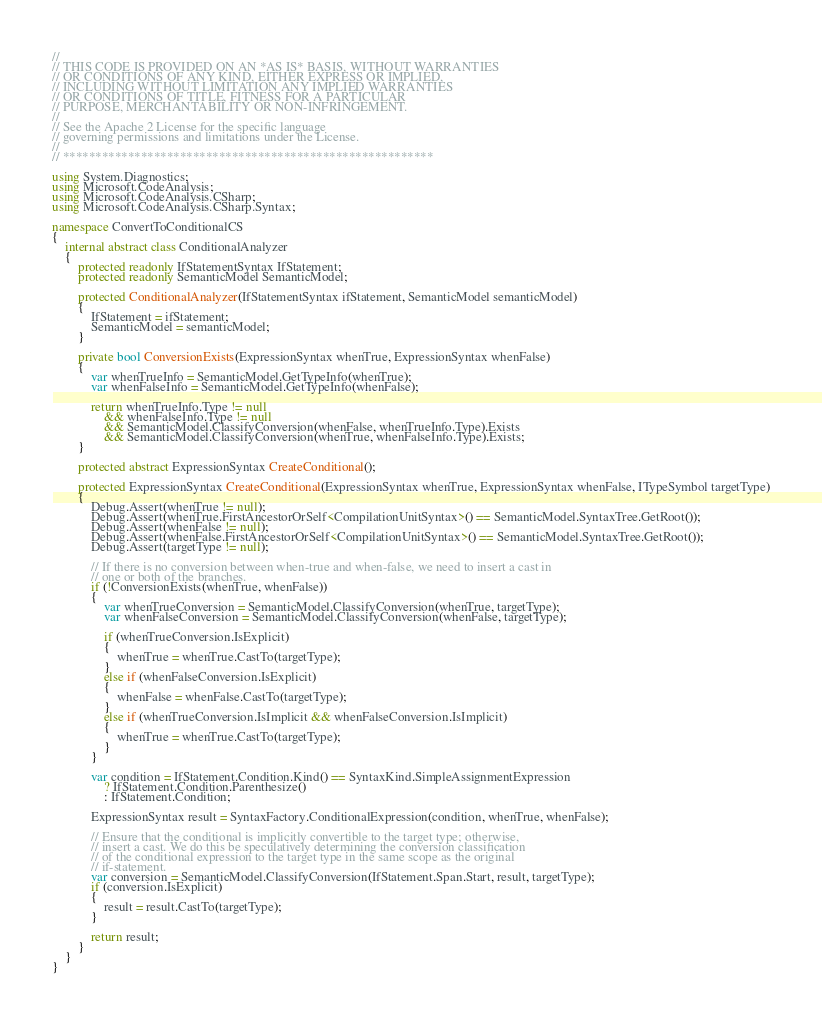<code> <loc_0><loc_0><loc_500><loc_500><_C#_>//
// THIS CODE IS PROVIDED ON AN *AS IS* BASIS, WITHOUT WARRANTIES
// OR CONDITIONS OF ANY KIND, EITHER EXPRESS OR IMPLIED,
// INCLUDING WITHOUT LIMITATION ANY IMPLIED WARRANTIES
// OR CONDITIONS OF TITLE, FITNESS FOR A PARTICULAR
// PURPOSE, MERCHANTABILITY OR NON-INFRINGEMENT.
//
// See the Apache 2 License for the specific language
// governing permissions and limitations under the License.
//
// *********************************************************

using System.Diagnostics;
using Microsoft.CodeAnalysis;
using Microsoft.CodeAnalysis.CSharp;
using Microsoft.CodeAnalysis.CSharp.Syntax;

namespace ConvertToConditionalCS
{
    internal abstract class ConditionalAnalyzer
    {
        protected readonly IfStatementSyntax IfStatement;
        protected readonly SemanticModel SemanticModel;

        protected ConditionalAnalyzer(IfStatementSyntax ifStatement, SemanticModel semanticModel)
        {
            IfStatement = ifStatement;
            SemanticModel = semanticModel;
        }

        private bool ConversionExists(ExpressionSyntax whenTrue, ExpressionSyntax whenFalse)
        {
            var whenTrueInfo = SemanticModel.GetTypeInfo(whenTrue);
            var whenFalseInfo = SemanticModel.GetTypeInfo(whenFalse);

            return whenTrueInfo.Type != null
                && whenFalseInfo.Type != null
                && SemanticModel.ClassifyConversion(whenFalse, whenTrueInfo.Type).Exists
                && SemanticModel.ClassifyConversion(whenTrue, whenFalseInfo.Type).Exists;
        }

        protected abstract ExpressionSyntax CreateConditional();

        protected ExpressionSyntax CreateConditional(ExpressionSyntax whenTrue, ExpressionSyntax whenFalse, ITypeSymbol targetType)
        {
            Debug.Assert(whenTrue != null);
            Debug.Assert(whenTrue.FirstAncestorOrSelf<CompilationUnitSyntax>() == SemanticModel.SyntaxTree.GetRoot());
            Debug.Assert(whenFalse != null);
            Debug.Assert(whenFalse.FirstAncestorOrSelf<CompilationUnitSyntax>() == SemanticModel.SyntaxTree.GetRoot());
            Debug.Assert(targetType != null);

            // If there is no conversion between when-true and when-false, we need to insert a cast in
            // one or both of the branches.
            if (!ConversionExists(whenTrue, whenFalse))
            {
                var whenTrueConversion = SemanticModel.ClassifyConversion(whenTrue, targetType);
                var whenFalseConversion = SemanticModel.ClassifyConversion(whenFalse, targetType);

                if (whenTrueConversion.IsExplicit)
                {
                    whenTrue = whenTrue.CastTo(targetType);
                }
                else if (whenFalseConversion.IsExplicit)
                {
                    whenFalse = whenFalse.CastTo(targetType);
                }
                else if (whenTrueConversion.IsImplicit && whenFalseConversion.IsImplicit)
                {
                    whenTrue = whenTrue.CastTo(targetType);
                }
            }

            var condition = IfStatement.Condition.Kind() == SyntaxKind.SimpleAssignmentExpression
                ? IfStatement.Condition.Parenthesize()
                : IfStatement.Condition;

            ExpressionSyntax result = SyntaxFactory.ConditionalExpression(condition, whenTrue, whenFalse);

            // Ensure that the conditional is implicitly convertible to the target type; otherwise,
            // insert a cast. We do this be speculatively determining the conversion classification
            // of the conditional expression to the target type in the same scope as the original
            // if-statement.
            var conversion = SemanticModel.ClassifyConversion(IfStatement.Span.Start, result, targetType);
            if (conversion.IsExplicit)
            {
                result = result.CastTo(targetType);
            }

            return result;
        }
    }
}
</code> 